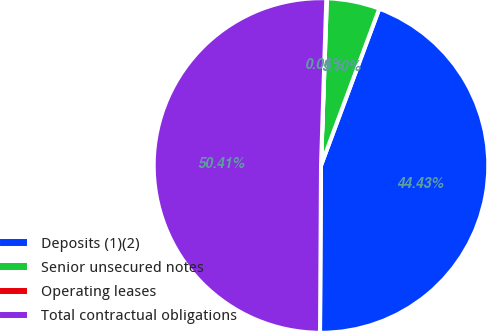Convert chart. <chart><loc_0><loc_0><loc_500><loc_500><pie_chart><fcel>Deposits (1)(2)<fcel>Senior unsecured notes<fcel>Operating leases<fcel>Total contractual obligations<nl><fcel>44.43%<fcel>5.1%<fcel>0.06%<fcel>50.41%<nl></chart> 